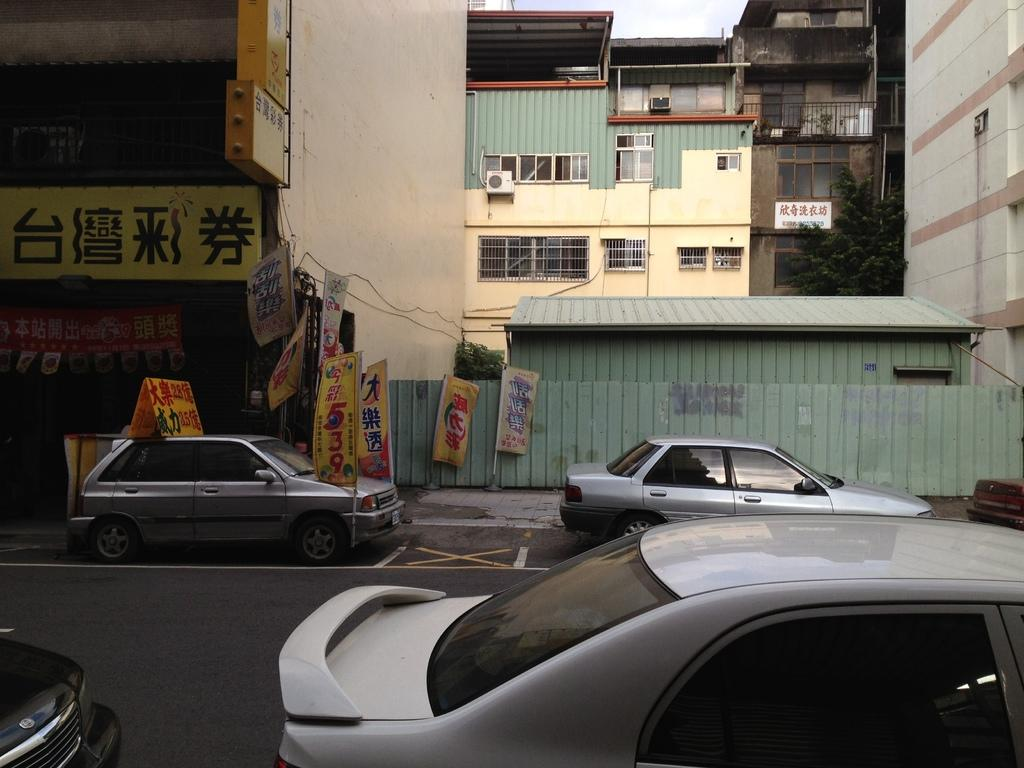What can be seen on the road in the image? There are vehicles on the road in the image. What is visible in the background of the image? There are buildings with windows in the background of the image. What type of signage is present in the image? There are banners in the image. What kind of barrier is present in the image? There is a fencing in the image. What type of vegetation is present in the image? There are trees in the image. What type of haircut is being given to the cabbage in the image? There is no cabbage or haircut present in the image. What type of pollution is visible in the image? There is no reference to pollution in the image, so it cannot be determined from the image. 